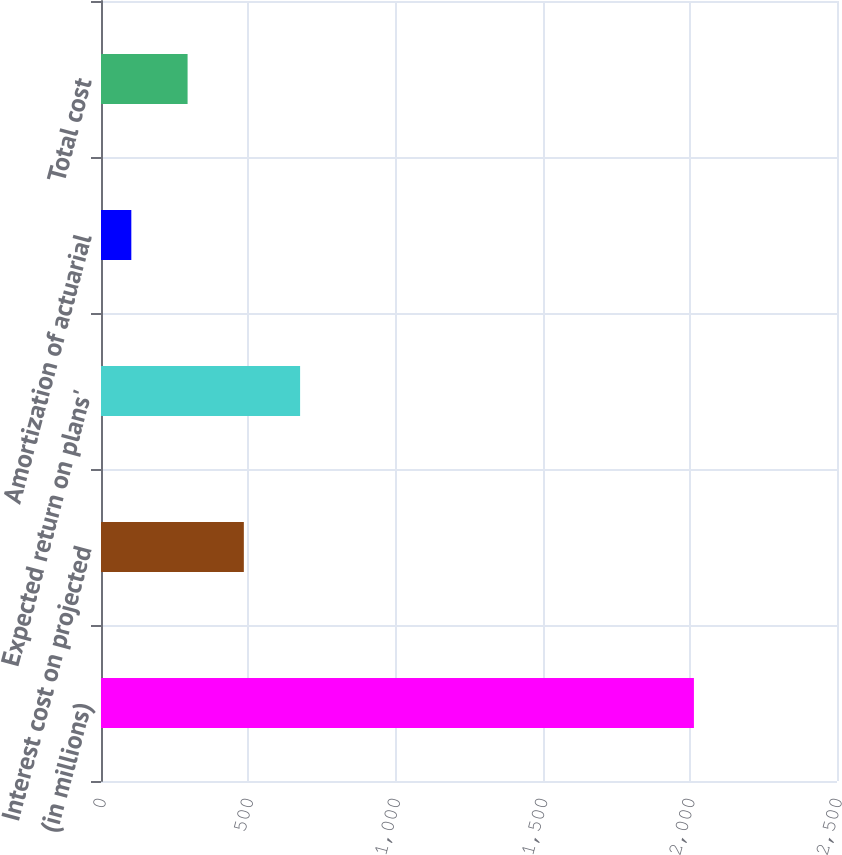<chart> <loc_0><loc_0><loc_500><loc_500><bar_chart><fcel>(in millions)<fcel>Interest cost on projected<fcel>Expected return on plans'<fcel>Amortization of actuarial<fcel>Total cost<nl><fcel>2014<fcel>485.2<fcel>676.3<fcel>103<fcel>294.1<nl></chart> 